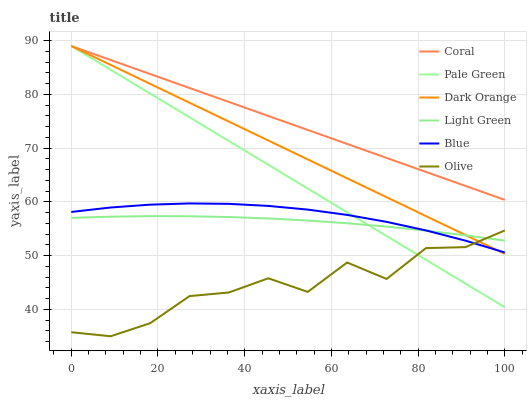Does Olive have the minimum area under the curve?
Answer yes or no. Yes. Does Coral have the maximum area under the curve?
Answer yes or no. Yes. Does Dark Orange have the minimum area under the curve?
Answer yes or no. No. Does Dark Orange have the maximum area under the curve?
Answer yes or no. No. Is Pale Green the smoothest?
Answer yes or no. Yes. Is Olive the roughest?
Answer yes or no. Yes. Is Dark Orange the smoothest?
Answer yes or no. No. Is Dark Orange the roughest?
Answer yes or no. No. Does Olive have the lowest value?
Answer yes or no. Yes. Does Dark Orange have the lowest value?
Answer yes or no. No. Does Pale Green have the highest value?
Answer yes or no. Yes. Does Light Green have the highest value?
Answer yes or no. No. Is Light Green less than Coral?
Answer yes or no. Yes. Is Coral greater than Blue?
Answer yes or no. Yes. Does Blue intersect Pale Green?
Answer yes or no. Yes. Is Blue less than Pale Green?
Answer yes or no. No. Is Blue greater than Pale Green?
Answer yes or no. No. Does Light Green intersect Coral?
Answer yes or no. No. 